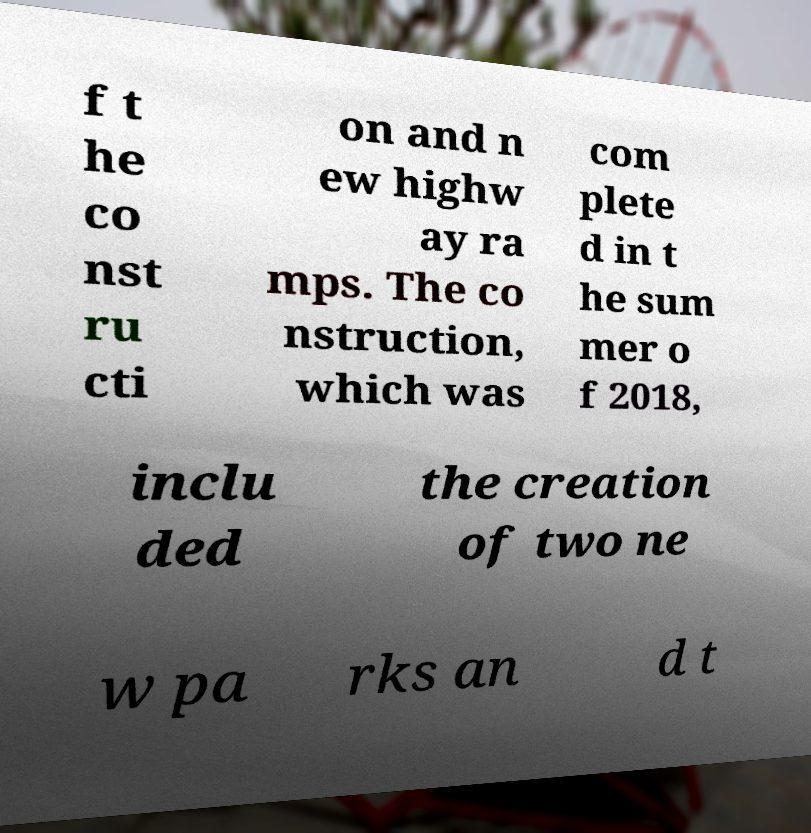Could you extract and type out the text from this image? f t he co nst ru cti on and n ew highw ay ra mps. The co nstruction, which was com plete d in t he sum mer o f 2018, inclu ded the creation of two ne w pa rks an d t 